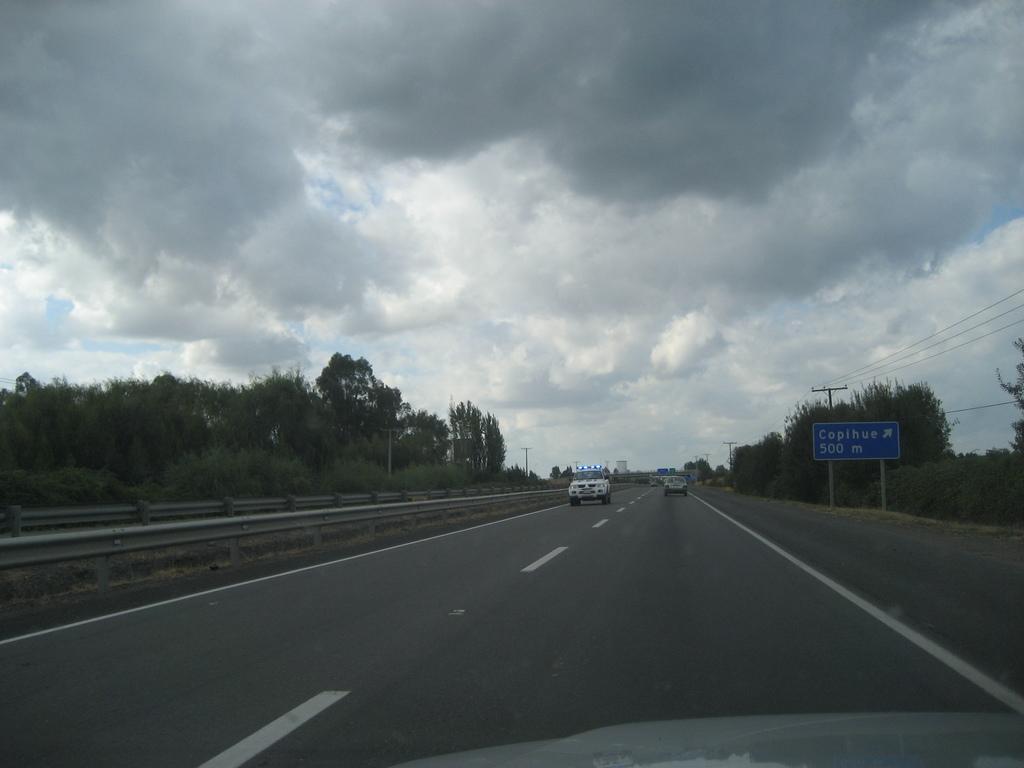How would you summarize this image in a sentence or two? In this image, we can see some vehicles, trees, plants, poles, wires. We can see the ground with some objects. We can see a board with some text. We can see the sky with clouds. 